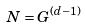Convert formula to latex. <formula><loc_0><loc_0><loc_500><loc_500>N = G ^ { ( d - 1 ) }</formula> 